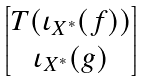Convert formula to latex. <formula><loc_0><loc_0><loc_500><loc_500>\begin{bmatrix} T ( \iota _ { X ^ { * } } ( f ) ) \\ \iota _ { X ^ { * } } ( g ) \end{bmatrix}</formula> 